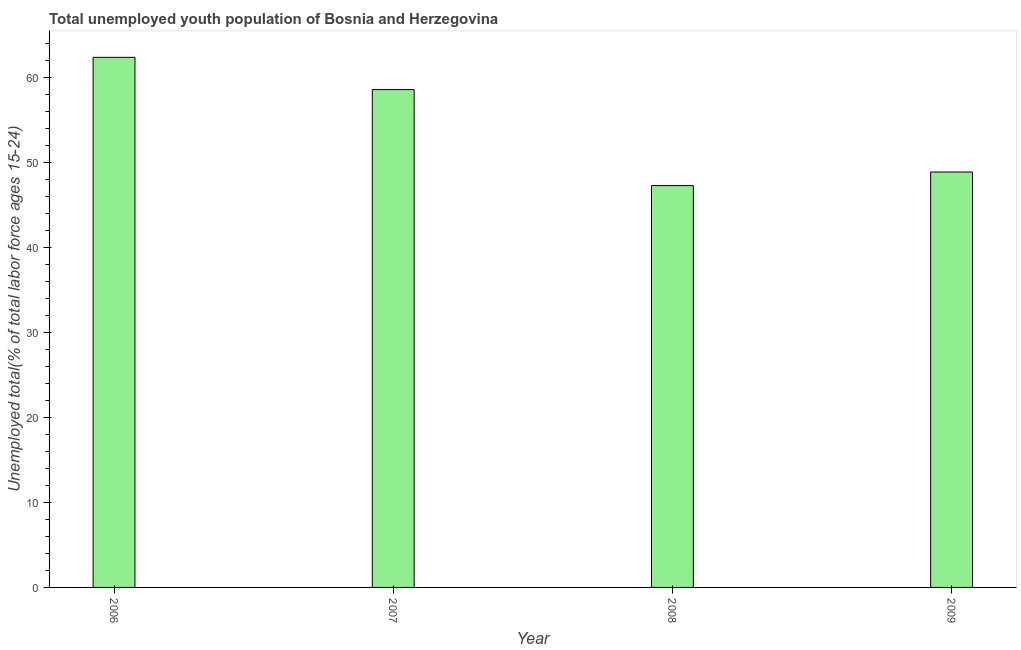Does the graph contain any zero values?
Your answer should be very brief. No. Does the graph contain grids?
Ensure brevity in your answer.  No. What is the title of the graph?
Your answer should be very brief. Total unemployed youth population of Bosnia and Herzegovina. What is the label or title of the X-axis?
Keep it short and to the point. Year. What is the label or title of the Y-axis?
Offer a very short reply. Unemployed total(% of total labor force ages 15-24). What is the unemployed youth in 2006?
Offer a terse response. 62.4. Across all years, what is the maximum unemployed youth?
Offer a very short reply. 62.4. Across all years, what is the minimum unemployed youth?
Offer a very short reply. 47.3. In which year was the unemployed youth maximum?
Your response must be concise. 2006. In which year was the unemployed youth minimum?
Offer a very short reply. 2008. What is the sum of the unemployed youth?
Offer a terse response. 217.2. What is the difference between the unemployed youth in 2006 and 2009?
Offer a very short reply. 13.5. What is the average unemployed youth per year?
Your response must be concise. 54.3. What is the median unemployed youth?
Give a very brief answer. 53.75. Do a majority of the years between 2008 and 2009 (inclusive) have unemployed youth greater than 26 %?
Give a very brief answer. Yes. What is the ratio of the unemployed youth in 2008 to that in 2009?
Provide a succinct answer. 0.97. Is the sum of the unemployed youth in 2007 and 2008 greater than the maximum unemployed youth across all years?
Your response must be concise. Yes. What is the difference between the highest and the lowest unemployed youth?
Provide a succinct answer. 15.1. In how many years, is the unemployed youth greater than the average unemployed youth taken over all years?
Make the answer very short. 2. How many bars are there?
Make the answer very short. 4. How many years are there in the graph?
Provide a succinct answer. 4. What is the difference between two consecutive major ticks on the Y-axis?
Your answer should be compact. 10. What is the Unemployed total(% of total labor force ages 15-24) of 2006?
Offer a very short reply. 62.4. What is the Unemployed total(% of total labor force ages 15-24) in 2007?
Your response must be concise. 58.6. What is the Unemployed total(% of total labor force ages 15-24) in 2008?
Offer a terse response. 47.3. What is the Unemployed total(% of total labor force ages 15-24) in 2009?
Your response must be concise. 48.9. What is the difference between the Unemployed total(% of total labor force ages 15-24) in 2006 and 2009?
Give a very brief answer. 13.5. What is the difference between the Unemployed total(% of total labor force ages 15-24) in 2007 and 2008?
Keep it short and to the point. 11.3. What is the ratio of the Unemployed total(% of total labor force ages 15-24) in 2006 to that in 2007?
Make the answer very short. 1.06. What is the ratio of the Unemployed total(% of total labor force ages 15-24) in 2006 to that in 2008?
Make the answer very short. 1.32. What is the ratio of the Unemployed total(% of total labor force ages 15-24) in 2006 to that in 2009?
Your response must be concise. 1.28. What is the ratio of the Unemployed total(% of total labor force ages 15-24) in 2007 to that in 2008?
Offer a terse response. 1.24. What is the ratio of the Unemployed total(% of total labor force ages 15-24) in 2007 to that in 2009?
Give a very brief answer. 1.2. What is the ratio of the Unemployed total(% of total labor force ages 15-24) in 2008 to that in 2009?
Your answer should be compact. 0.97. 